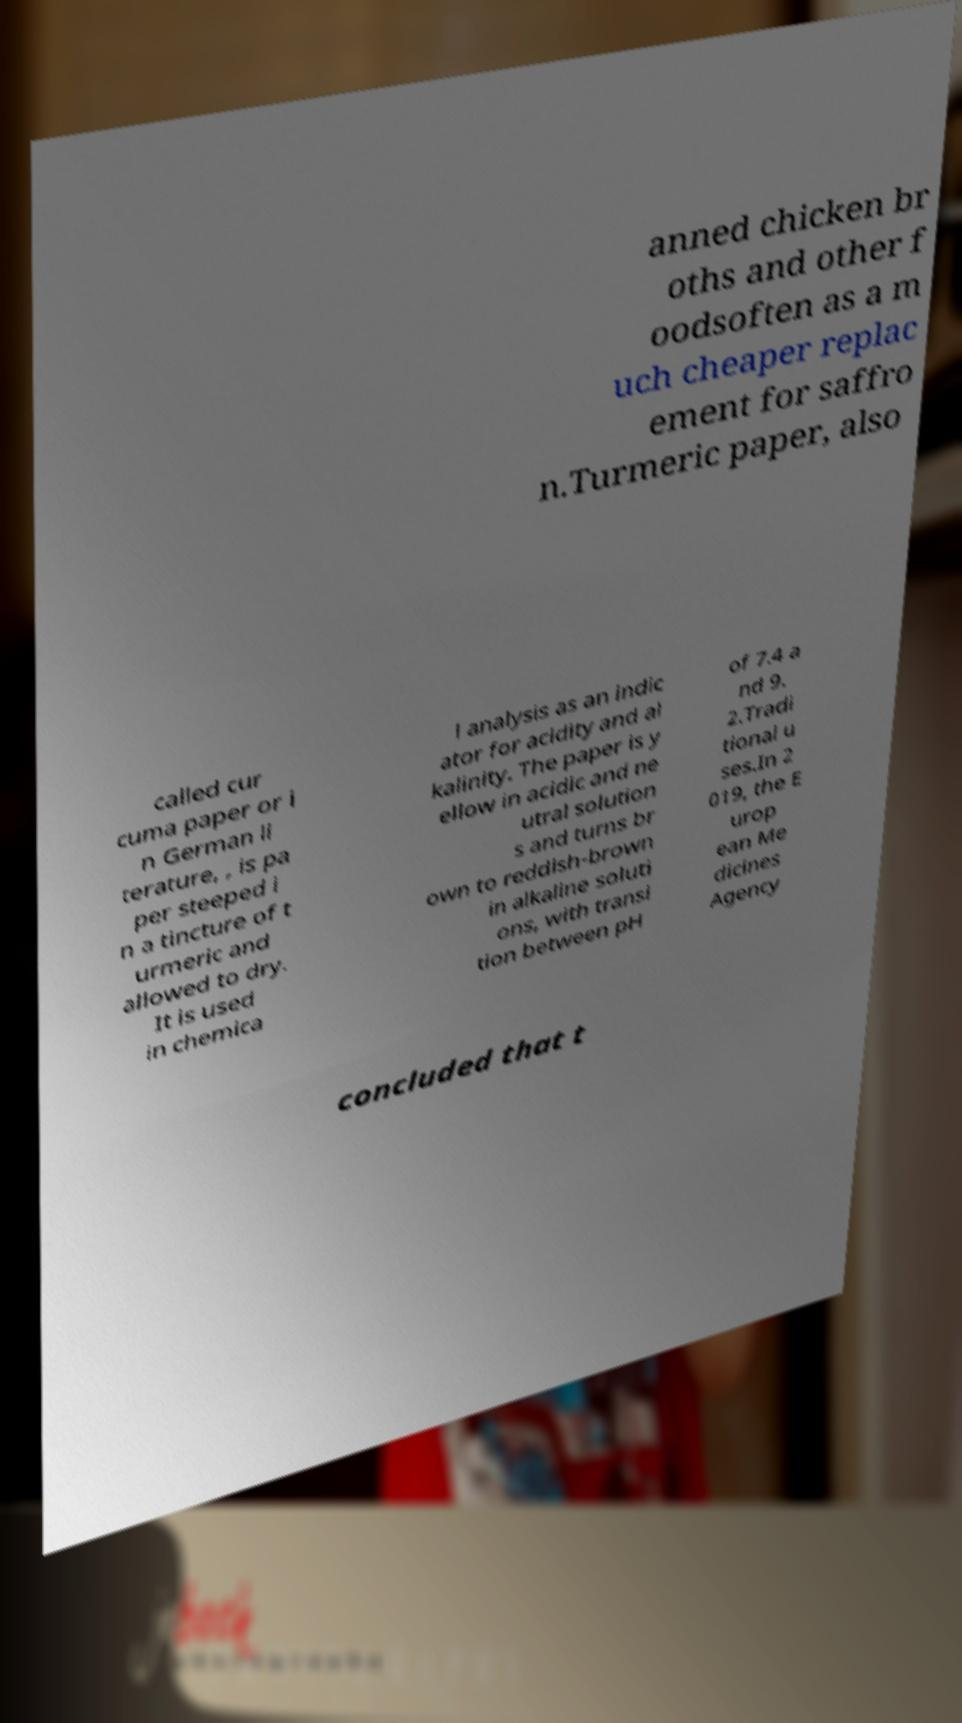Can you read and provide the text displayed in the image?This photo seems to have some interesting text. Can you extract and type it out for me? anned chicken br oths and other f oodsoften as a m uch cheaper replac ement for saffro n.Turmeric paper, also called cur cuma paper or i n German li terature, , is pa per steeped i n a tincture of t urmeric and allowed to dry. It is used in chemica l analysis as an indic ator for acidity and al kalinity. The paper is y ellow in acidic and ne utral solution s and turns br own to reddish-brown in alkaline soluti ons, with transi tion between pH of 7.4 a nd 9. 2.Tradi tional u ses.In 2 019, the E urop ean Me dicines Agency concluded that t 